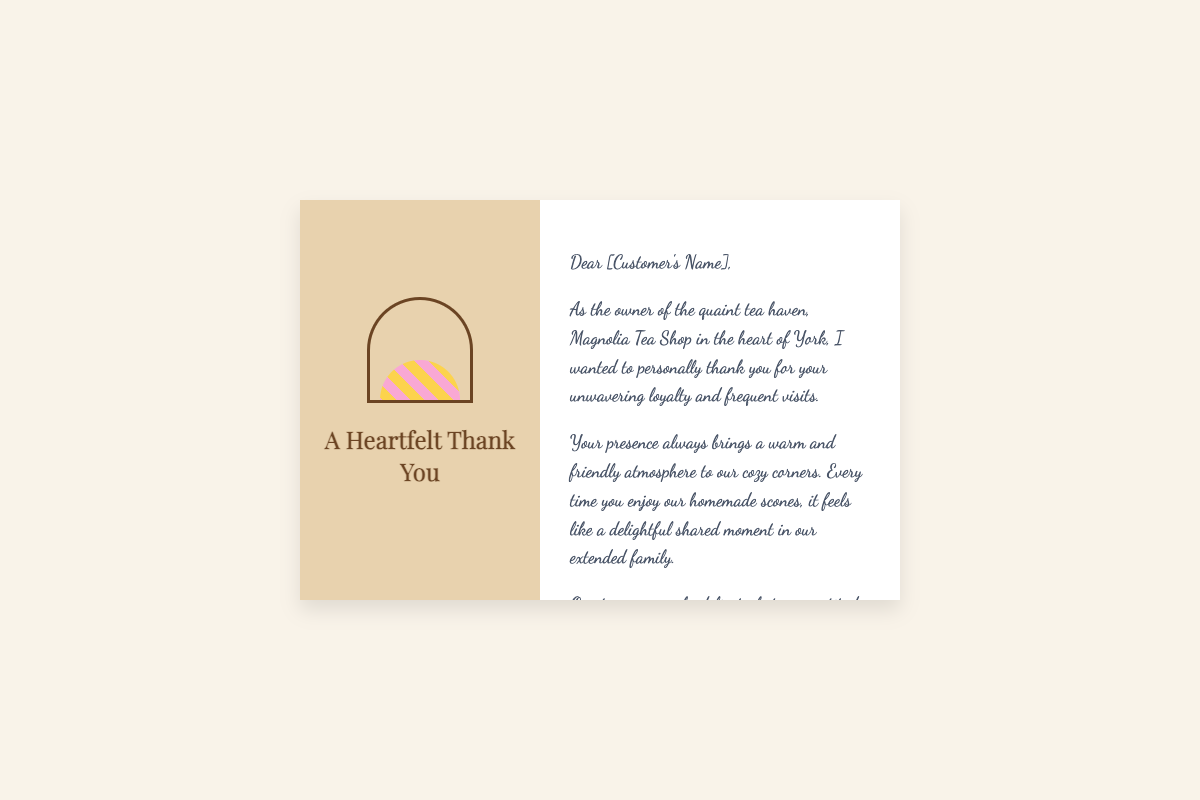What is the name of the tea shop? The document mentions the tea shop's name as Magnolia Tea Shop.
Answer: Magnolia Tea Shop Who is the owner of the tea shop? The handwritten note includes the name of the owner at the end, which is Jane Doe.
Answer: Jane Doe What color is the teacup? The teacup design includes a border color that is specified as #6b4423, which translates to a brown color.
Answer: Brown What message is conveyed on the cover? The cover of the card displays the title "A Heartfelt Thank You."
Answer: A Heartfelt Thank You How does the owner describe the customer’s presence? The note states that the customer's presence brings a warm and friendly atmosphere to the shop.
Answer: Warm and friendly atmosphere What type of baked goods does the tea shop serve? The document mentions that the tea shop is known for its delicious homemade scones.
Answer: Homemade scones What is the message's tone towards the customer? The tone of the message is one of gratitude and warmth towards the customer for their loyalty.
Answer: Gratitude and warmth What font style is used for the greeting? The cover and interior note uses the 'Playfair Display' serif font and the 'Dancing Script' cursive font.
Answer: Playfair Display and Dancing Script What does the owner say about tea time? The owner expresses that tea time is even more special because of the customer.
Answer: Even more special because of you! 